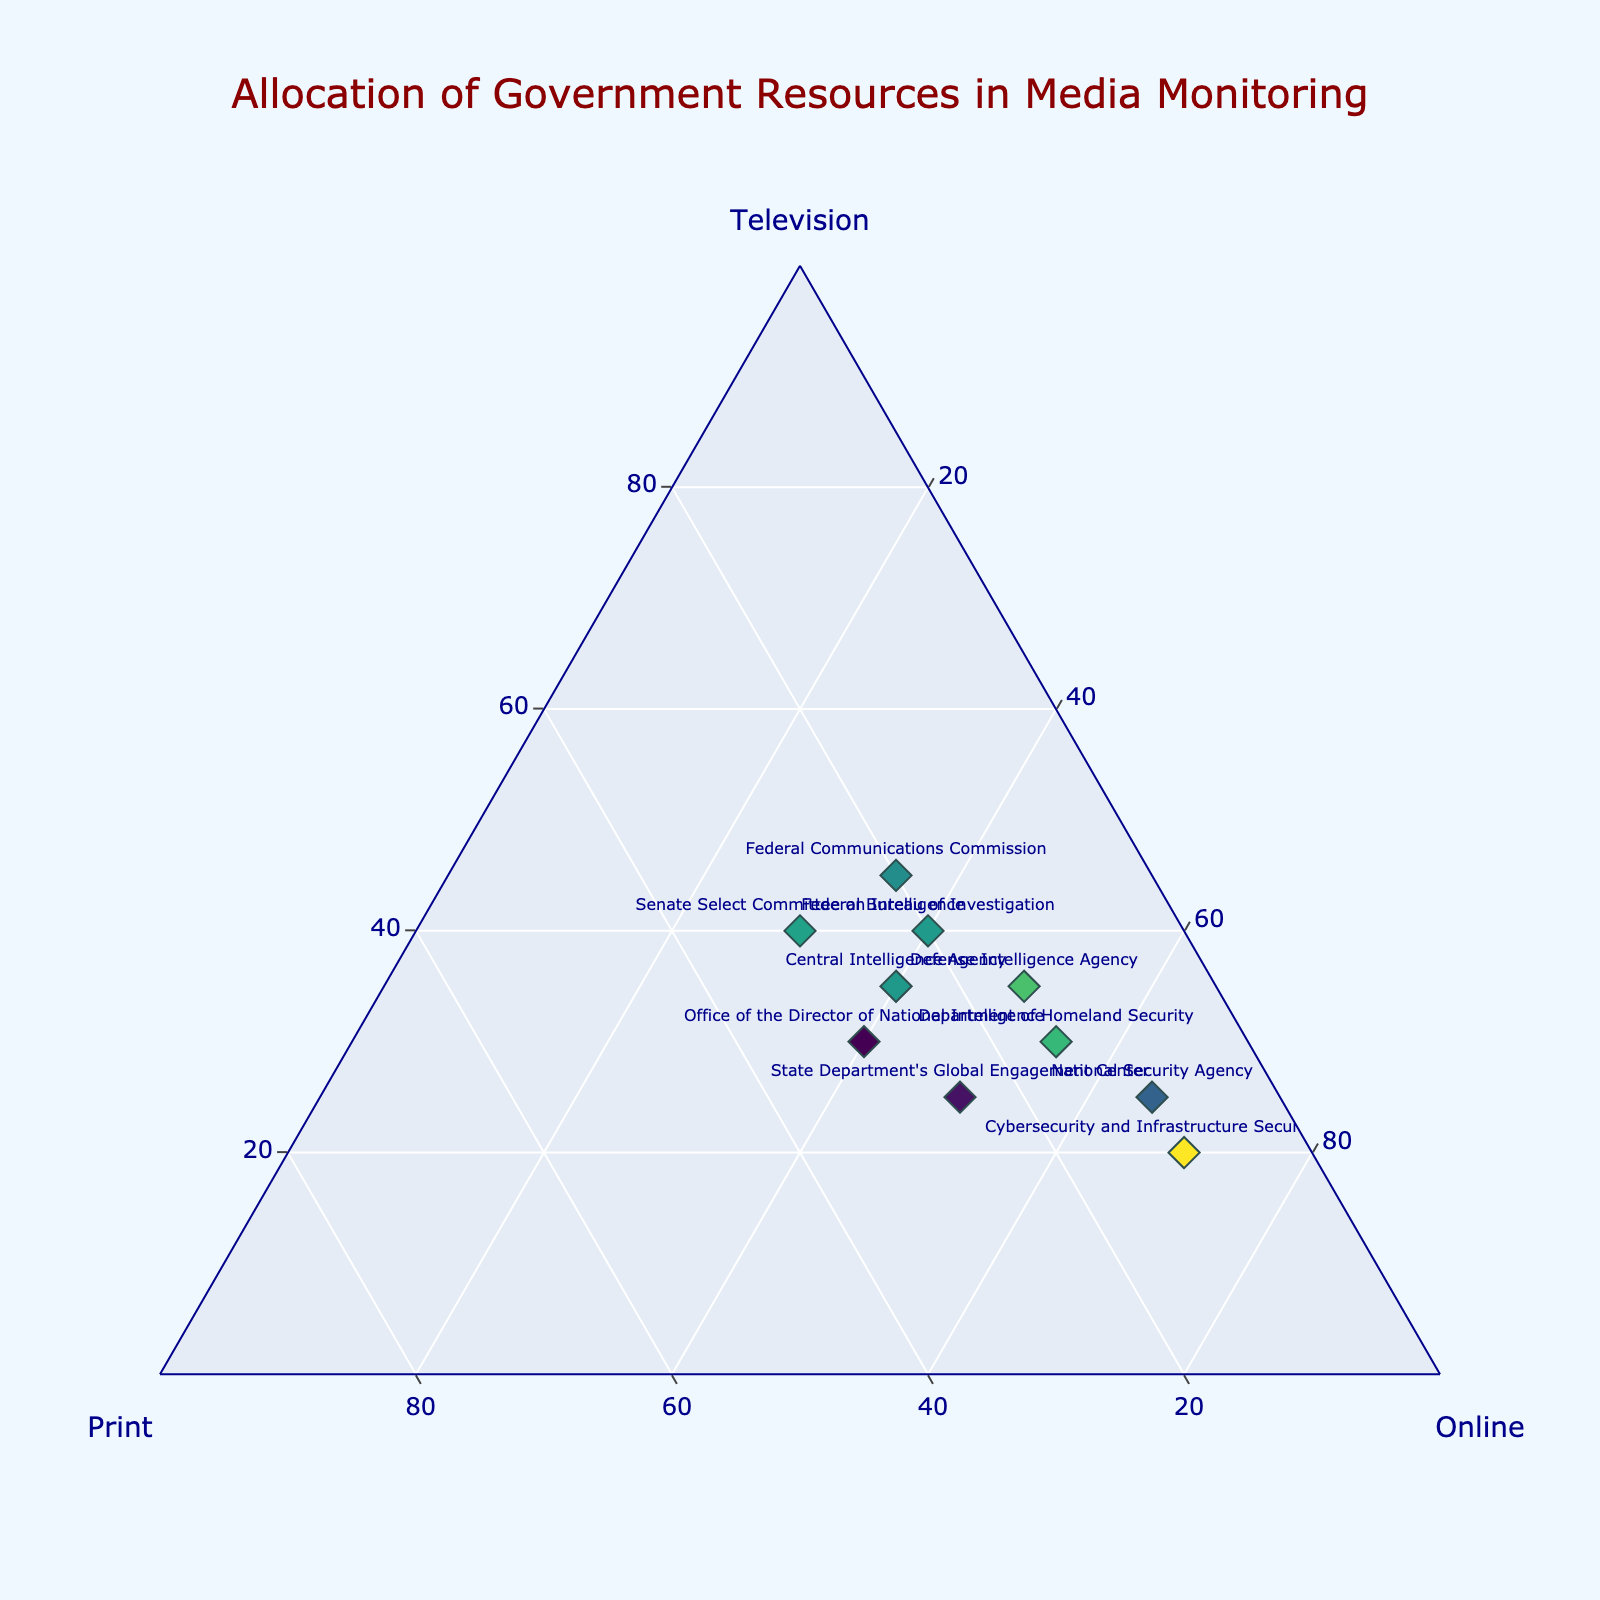What is the title of the plot? The title is displayed at the top center of the plot and is usually the most noticeable text element. In this case, the title indicates what the plot is about.
Answer: Allocation of Government Resources in Media Monitoring Which agency allocates the highest percentage of resources to Print media? By looking at the plot, identify the agency whose data point is closest to the Print (b) axis label. This agency allocates more resources to Print than the others.
Answer: Senate Select Committee on Intelligence Which agency allocates the lowest percentage of resources to Television? Find the agency whose data point is closest to the Television (a) axis label. The CISA is positioned toward the Online axis, indicating low allocation to Television.
Answer: Cybersecurity and Infrastructure Security Agency What is the difference in the allocation of resources to Online media between the Department of Homeland Security and the National Security Agency? Locate both agencies' data points, note their percentages for Online media, and compute the difference: DHS (55%) - NSA (65%).
Answer: 10% Which agency has an equal allocation of resources between Television and Print? Look for the data point that is positioned such that it is at an equal distance/ratio between the Television (a) and Print (b) axes. The ODNI fits this criterion with 30% each in Television and Print.
Answer: Office of the Director of National Intelligence How many agencies allocate more than 40% of their resources to Online media? Count the data points that are positioned farthest from the Online (c) axis label, indicating a higher percentage allocation to Online media.
Answer: Six Do any agencies allocate their resources equally across all three media types? To allocate resources equally, a data point must be positioned equidistant from all three axes, roughly in the center of the plot. No data point is in this central position.
Answer: No Which agency has the closest allocation values between Television and Online? Identify the data point with the smallest difference between the values of Television (a) and Online (c). The CIA has 35% in Television and 40% in Online, showing a close allocation.
Answer: Central Intelligence Agency What is the total percentage of resources for the Defense Intelligence Agency in both Print and Online media? Combine the values for Print and Online media by summing them: DIA Print (15%) + Online (50%).
Answer: 65% What is the primary platform focus for the FBI, based on their resource allocation? Determine which axis the FBI data point is closest to; it indicates the primary platform where most resources are allocated.
Answer: Television and Online 